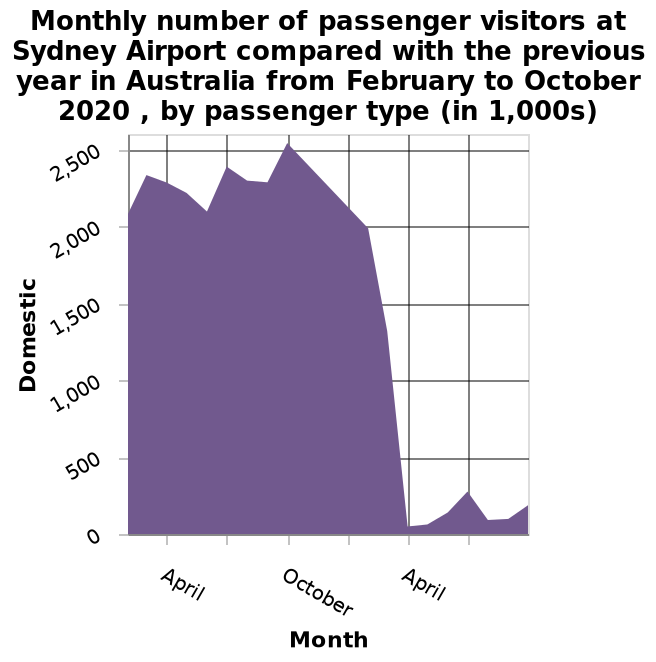<image>
What is the range of months included in the area chart? The area chart includes data from February to October. 